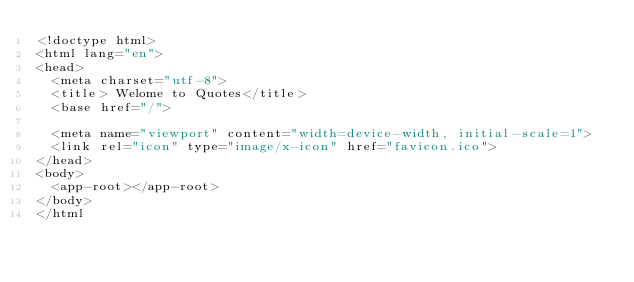Convert code to text. <code><loc_0><loc_0><loc_500><loc_500><_HTML_><!doctype html>
<html lang="en">
<head>
  <meta charset="utf-8">
  <title> Welome to Quotes</title>
  <base href="/">

  <meta name="viewport" content="width=device-width, initial-scale=1">
  <link rel="icon" type="image/x-icon" href="favicon.ico">
</head>
<body>
  <app-root></app-root>
</body>
</html</code> 